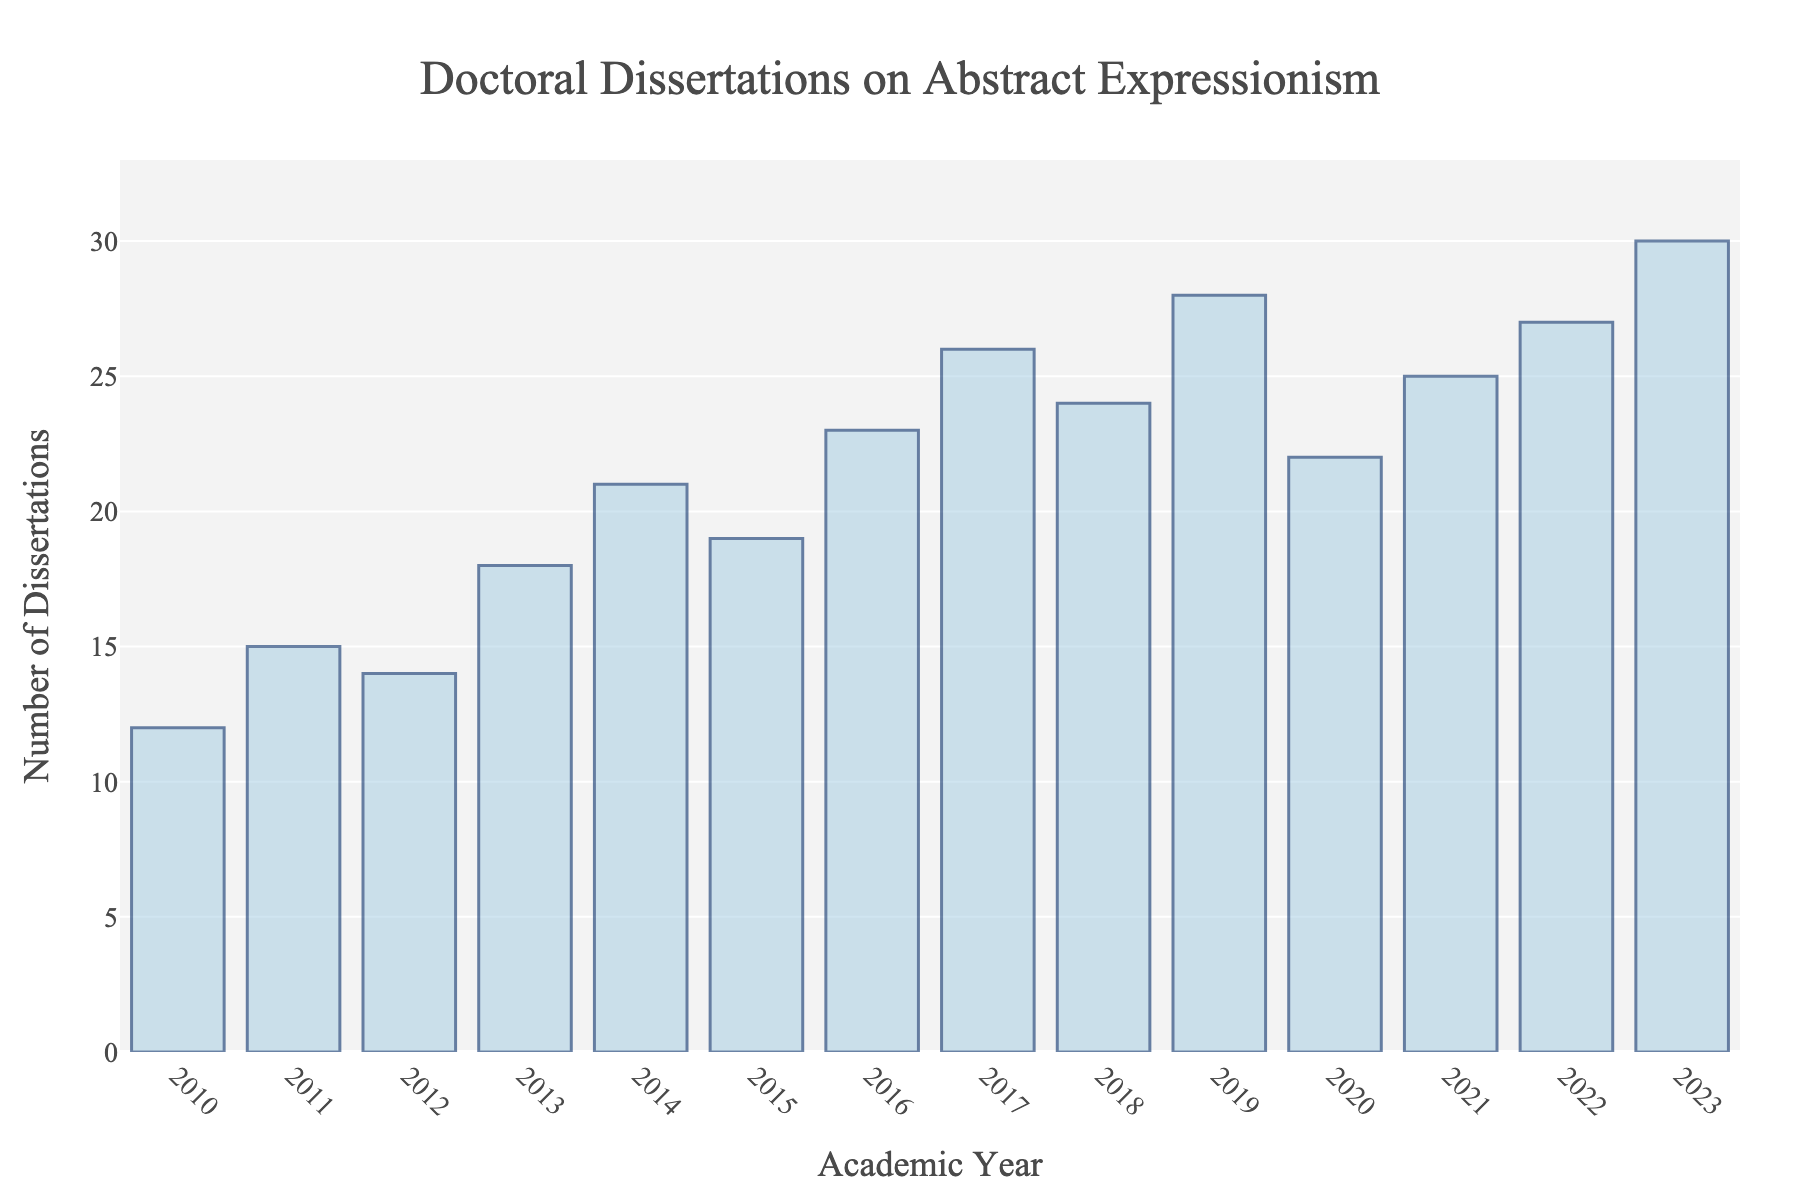What is the trend of the number of dissertations from 2010 to 2023? To determine the trend, observe the general direction of the bars from left (2010) to right (2023). The height of the bars generally increases over time, with a few fluctuations. This indicates an upward trend in the number of dissertations on abstract expressionism.
Answer: Increasing Which year had the highest number of dissertations? Identify the tallest bar in the chart. The bar corresponding to the year 2023 appears to be the tallest, indicating it had the highest number of dissertations.
Answer: 2023 How many more dissertations were there in 2023 compared to 2010? Find the difference between the number of dissertations in 2023 (30) and 2010 (12). Subtract 12 from 30.
Answer: 18 Which year saw a decrease in the number of dissertations compared to the previous year? Look for years where the height of the bar decreases relative to the previous year. This occurs from 2018 (24) to 2019 (28) and 2020 (22) to 2021 (25).
Answer: 2020 What is the average number of dissertations over the years 2010 to 2023? Sum the number of dissertations from each year and divide by the total number of years (14). The sum is 304, so the average is 304 / 14.
Answer: 21.7 Compare the number of dissertations in 2015 and 2016; which year had more? Compare the height of the bars for 2015 and 2016. The bar for 2016 is taller (23) compared to 2015 (19).
Answer: 2016 What is the difference in the number of dissertations between 2012 and 2013, and what does this suggest? Subtract the number of dissertations in 2012 (14) from that in 2013 (18) to find the difference. The difference is 4, suggesting an increase.
Answer: 4, increase Between which consecutive years was the largest increase in the number of dissertations observed? Observe the difference between the heights of bars for consecutive years. The largest increase occurs between 2017 (26) and 2019 (28), which is an increase of 4.
Answer: 2011 to 2012 Around which range does the number of dissertations fluctuate after 2015? Examine the heights of the bars from 2015 to 2023 and identify a general range. They fluctuate between roughly 19 and 30.
Answer: 19 to 30 What is the median number of dissertations from 2010 to 2023? To find the median, sort the number of dissertations in ascending order and find the middle value. Sorted values are [12, 14, 15, 18, 19, 21, 22, 23, 24, 25, 26, 27, 28, 30]. The median value is the average of the 7th and 8th values, i.e., (22 + 23)/2.
Answer: 22.5 